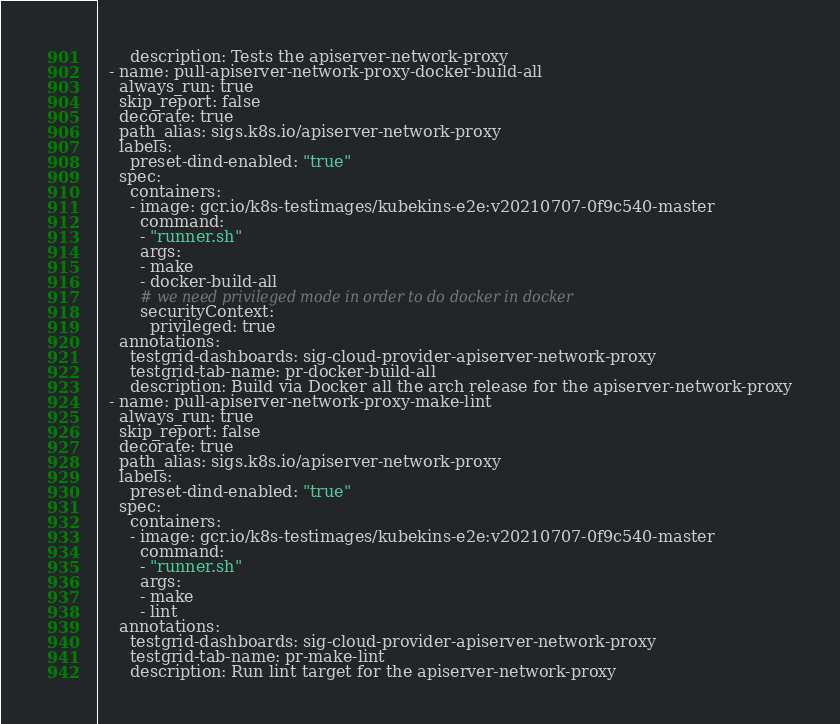<code> <loc_0><loc_0><loc_500><loc_500><_YAML_>      description: Tests the apiserver-network-proxy
  - name: pull-apiserver-network-proxy-docker-build-all
    always_run: true
    skip_report: false
    decorate: true
    path_alias: sigs.k8s.io/apiserver-network-proxy
    labels:
      preset-dind-enabled: "true"
    spec:
      containers:
      - image: gcr.io/k8s-testimages/kubekins-e2e:v20210707-0f9c540-master
        command:
        - "runner.sh"
        args:
        - make
        - docker-build-all
        # we need privileged mode in order to do docker in docker
        securityContext:
          privileged: true
    annotations:
      testgrid-dashboards: sig-cloud-provider-apiserver-network-proxy
      testgrid-tab-name: pr-docker-build-all
      description: Build via Docker all the arch release for the apiserver-network-proxy
  - name: pull-apiserver-network-proxy-make-lint
    always_run: true
    skip_report: false
    decorate: true
    path_alias: sigs.k8s.io/apiserver-network-proxy
    labels:
      preset-dind-enabled: "true"
    spec:
      containers:
      - image: gcr.io/k8s-testimages/kubekins-e2e:v20210707-0f9c540-master
        command:
        - "runner.sh"
        args:
        - make
        - lint
    annotations:
      testgrid-dashboards: sig-cloud-provider-apiserver-network-proxy
      testgrid-tab-name: pr-make-lint
      description: Run lint target for the apiserver-network-proxy
</code> 